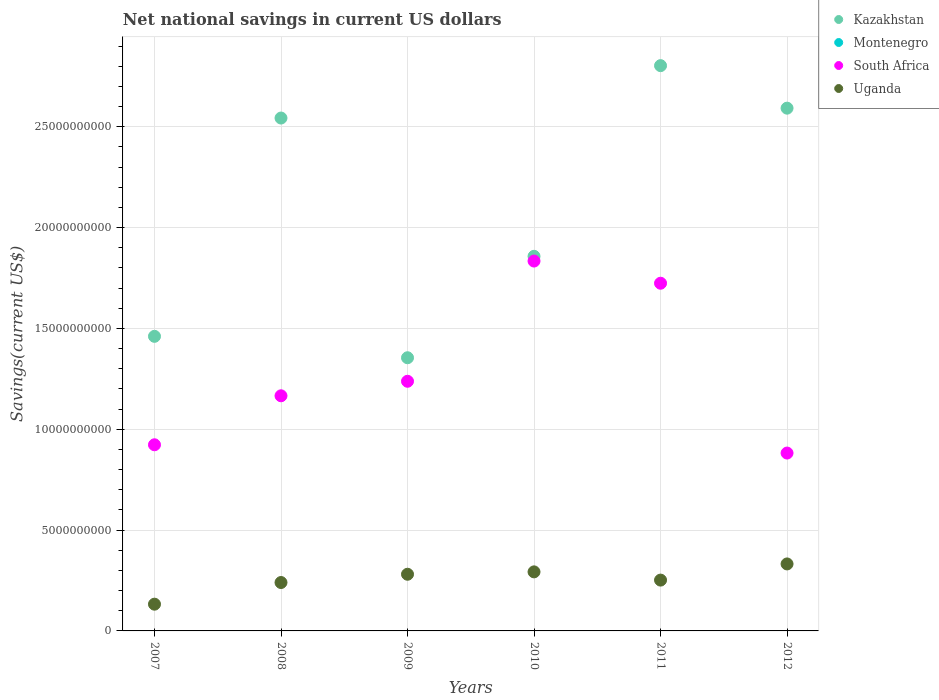What is the net national savings in Uganda in 2008?
Provide a succinct answer. 2.40e+09. Across all years, what is the maximum net national savings in Uganda?
Your answer should be very brief. 3.32e+09. Across all years, what is the minimum net national savings in Kazakhstan?
Your answer should be compact. 1.35e+1. What is the difference between the net national savings in South Africa in 2009 and that in 2012?
Keep it short and to the point. 3.56e+09. What is the difference between the net national savings in Montenegro in 2011 and the net national savings in Uganda in 2007?
Your response must be concise. -1.33e+09. What is the average net national savings in South Africa per year?
Offer a very short reply. 1.29e+1. In the year 2009, what is the difference between the net national savings in South Africa and net national savings in Uganda?
Offer a very short reply. 9.57e+09. What is the ratio of the net national savings in South Africa in 2007 to that in 2012?
Your answer should be very brief. 1.05. Is the net national savings in Uganda in 2008 less than that in 2011?
Your answer should be very brief. Yes. What is the difference between the highest and the second highest net national savings in Kazakhstan?
Provide a short and direct response. 2.11e+09. What is the difference between the highest and the lowest net national savings in South Africa?
Provide a succinct answer. 9.52e+09. Is it the case that in every year, the sum of the net national savings in Kazakhstan and net national savings in Uganda  is greater than the net national savings in Montenegro?
Offer a very short reply. Yes. Is the net national savings in Uganda strictly less than the net national savings in Kazakhstan over the years?
Provide a short and direct response. Yes. How many dotlines are there?
Keep it short and to the point. 3. Are the values on the major ticks of Y-axis written in scientific E-notation?
Your answer should be very brief. No. Does the graph contain any zero values?
Give a very brief answer. Yes. What is the title of the graph?
Your response must be concise. Net national savings in current US dollars. Does "Malaysia" appear as one of the legend labels in the graph?
Offer a terse response. No. What is the label or title of the Y-axis?
Ensure brevity in your answer.  Savings(current US$). What is the Savings(current US$) of Kazakhstan in 2007?
Give a very brief answer. 1.46e+1. What is the Savings(current US$) in South Africa in 2007?
Keep it short and to the point. 9.23e+09. What is the Savings(current US$) in Uganda in 2007?
Offer a terse response. 1.33e+09. What is the Savings(current US$) of Kazakhstan in 2008?
Give a very brief answer. 2.54e+1. What is the Savings(current US$) of South Africa in 2008?
Offer a very short reply. 1.17e+1. What is the Savings(current US$) of Uganda in 2008?
Provide a succinct answer. 2.40e+09. What is the Savings(current US$) of Kazakhstan in 2009?
Make the answer very short. 1.35e+1. What is the Savings(current US$) in South Africa in 2009?
Offer a terse response. 1.24e+1. What is the Savings(current US$) in Uganda in 2009?
Ensure brevity in your answer.  2.81e+09. What is the Savings(current US$) of Kazakhstan in 2010?
Offer a terse response. 1.86e+1. What is the Savings(current US$) in Montenegro in 2010?
Provide a short and direct response. 0. What is the Savings(current US$) in South Africa in 2010?
Provide a short and direct response. 1.83e+1. What is the Savings(current US$) of Uganda in 2010?
Your answer should be very brief. 2.93e+09. What is the Savings(current US$) of Kazakhstan in 2011?
Your answer should be very brief. 2.80e+1. What is the Savings(current US$) of Montenegro in 2011?
Your answer should be very brief. 0. What is the Savings(current US$) in South Africa in 2011?
Provide a succinct answer. 1.72e+1. What is the Savings(current US$) in Uganda in 2011?
Provide a succinct answer. 2.52e+09. What is the Savings(current US$) in Kazakhstan in 2012?
Offer a very short reply. 2.59e+1. What is the Savings(current US$) in South Africa in 2012?
Provide a succinct answer. 8.82e+09. What is the Savings(current US$) of Uganda in 2012?
Your response must be concise. 3.32e+09. Across all years, what is the maximum Savings(current US$) of Kazakhstan?
Your answer should be very brief. 2.80e+1. Across all years, what is the maximum Savings(current US$) in South Africa?
Offer a terse response. 1.83e+1. Across all years, what is the maximum Savings(current US$) of Uganda?
Your response must be concise. 3.32e+09. Across all years, what is the minimum Savings(current US$) of Kazakhstan?
Keep it short and to the point. 1.35e+1. Across all years, what is the minimum Savings(current US$) in South Africa?
Keep it short and to the point. 8.82e+09. Across all years, what is the minimum Savings(current US$) of Uganda?
Your answer should be very brief. 1.33e+09. What is the total Savings(current US$) of Kazakhstan in the graph?
Ensure brevity in your answer.  1.26e+11. What is the total Savings(current US$) of Montenegro in the graph?
Provide a short and direct response. 0. What is the total Savings(current US$) in South Africa in the graph?
Keep it short and to the point. 7.77e+1. What is the total Savings(current US$) in Uganda in the graph?
Your answer should be compact. 1.53e+1. What is the difference between the Savings(current US$) in Kazakhstan in 2007 and that in 2008?
Your answer should be very brief. -1.08e+1. What is the difference between the Savings(current US$) in South Africa in 2007 and that in 2008?
Your answer should be compact. -2.43e+09. What is the difference between the Savings(current US$) in Uganda in 2007 and that in 2008?
Provide a short and direct response. -1.07e+09. What is the difference between the Savings(current US$) in Kazakhstan in 2007 and that in 2009?
Your answer should be very brief. 1.06e+09. What is the difference between the Savings(current US$) of South Africa in 2007 and that in 2009?
Offer a terse response. -3.15e+09. What is the difference between the Savings(current US$) in Uganda in 2007 and that in 2009?
Keep it short and to the point. -1.48e+09. What is the difference between the Savings(current US$) of Kazakhstan in 2007 and that in 2010?
Give a very brief answer. -3.97e+09. What is the difference between the Savings(current US$) in South Africa in 2007 and that in 2010?
Your response must be concise. -9.11e+09. What is the difference between the Savings(current US$) of Uganda in 2007 and that in 2010?
Your answer should be very brief. -1.60e+09. What is the difference between the Savings(current US$) of Kazakhstan in 2007 and that in 2011?
Offer a terse response. -1.34e+1. What is the difference between the Savings(current US$) of South Africa in 2007 and that in 2011?
Your response must be concise. -8.01e+09. What is the difference between the Savings(current US$) in Uganda in 2007 and that in 2011?
Make the answer very short. -1.19e+09. What is the difference between the Savings(current US$) in Kazakhstan in 2007 and that in 2012?
Provide a short and direct response. -1.13e+1. What is the difference between the Savings(current US$) of South Africa in 2007 and that in 2012?
Provide a short and direct response. 4.10e+08. What is the difference between the Savings(current US$) in Uganda in 2007 and that in 2012?
Give a very brief answer. -2.00e+09. What is the difference between the Savings(current US$) in Kazakhstan in 2008 and that in 2009?
Give a very brief answer. 1.19e+1. What is the difference between the Savings(current US$) in South Africa in 2008 and that in 2009?
Make the answer very short. -7.20e+08. What is the difference between the Savings(current US$) of Uganda in 2008 and that in 2009?
Your answer should be compact. -4.10e+08. What is the difference between the Savings(current US$) in Kazakhstan in 2008 and that in 2010?
Your answer should be very brief. 6.86e+09. What is the difference between the Savings(current US$) of South Africa in 2008 and that in 2010?
Provide a short and direct response. -6.68e+09. What is the difference between the Savings(current US$) of Uganda in 2008 and that in 2010?
Your answer should be compact. -5.28e+08. What is the difference between the Savings(current US$) of Kazakhstan in 2008 and that in 2011?
Ensure brevity in your answer.  -2.60e+09. What is the difference between the Savings(current US$) in South Africa in 2008 and that in 2011?
Offer a terse response. -5.58e+09. What is the difference between the Savings(current US$) of Uganda in 2008 and that in 2011?
Your answer should be compact. -1.20e+08. What is the difference between the Savings(current US$) in Kazakhstan in 2008 and that in 2012?
Your response must be concise. -4.90e+08. What is the difference between the Savings(current US$) in South Africa in 2008 and that in 2012?
Ensure brevity in your answer.  2.84e+09. What is the difference between the Savings(current US$) of Uganda in 2008 and that in 2012?
Offer a very short reply. -9.22e+08. What is the difference between the Savings(current US$) in Kazakhstan in 2009 and that in 2010?
Make the answer very short. -5.03e+09. What is the difference between the Savings(current US$) in South Africa in 2009 and that in 2010?
Keep it short and to the point. -5.96e+09. What is the difference between the Savings(current US$) in Uganda in 2009 and that in 2010?
Provide a succinct answer. -1.18e+08. What is the difference between the Savings(current US$) of Kazakhstan in 2009 and that in 2011?
Your answer should be compact. -1.45e+1. What is the difference between the Savings(current US$) of South Africa in 2009 and that in 2011?
Your response must be concise. -4.86e+09. What is the difference between the Savings(current US$) of Uganda in 2009 and that in 2011?
Keep it short and to the point. 2.90e+08. What is the difference between the Savings(current US$) of Kazakhstan in 2009 and that in 2012?
Provide a short and direct response. -1.24e+1. What is the difference between the Savings(current US$) in South Africa in 2009 and that in 2012?
Keep it short and to the point. 3.56e+09. What is the difference between the Savings(current US$) in Uganda in 2009 and that in 2012?
Provide a succinct answer. -5.11e+08. What is the difference between the Savings(current US$) in Kazakhstan in 2010 and that in 2011?
Offer a very short reply. -9.46e+09. What is the difference between the Savings(current US$) in South Africa in 2010 and that in 2011?
Your answer should be compact. 1.10e+09. What is the difference between the Savings(current US$) in Uganda in 2010 and that in 2011?
Provide a short and direct response. 4.08e+08. What is the difference between the Savings(current US$) in Kazakhstan in 2010 and that in 2012?
Give a very brief answer. -7.35e+09. What is the difference between the Savings(current US$) of South Africa in 2010 and that in 2012?
Offer a terse response. 9.52e+09. What is the difference between the Savings(current US$) of Uganda in 2010 and that in 2012?
Ensure brevity in your answer.  -3.93e+08. What is the difference between the Savings(current US$) in Kazakhstan in 2011 and that in 2012?
Give a very brief answer. 2.11e+09. What is the difference between the Savings(current US$) of South Africa in 2011 and that in 2012?
Make the answer very short. 8.42e+09. What is the difference between the Savings(current US$) in Uganda in 2011 and that in 2012?
Your answer should be very brief. -8.02e+08. What is the difference between the Savings(current US$) of Kazakhstan in 2007 and the Savings(current US$) of South Africa in 2008?
Your response must be concise. 2.95e+09. What is the difference between the Savings(current US$) in Kazakhstan in 2007 and the Savings(current US$) in Uganda in 2008?
Your answer should be very brief. 1.22e+1. What is the difference between the Savings(current US$) of South Africa in 2007 and the Savings(current US$) of Uganda in 2008?
Give a very brief answer. 6.83e+09. What is the difference between the Savings(current US$) in Kazakhstan in 2007 and the Savings(current US$) in South Africa in 2009?
Ensure brevity in your answer.  2.23e+09. What is the difference between the Savings(current US$) of Kazakhstan in 2007 and the Savings(current US$) of Uganda in 2009?
Ensure brevity in your answer.  1.18e+1. What is the difference between the Savings(current US$) in South Africa in 2007 and the Savings(current US$) in Uganda in 2009?
Make the answer very short. 6.42e+09. What is the difference between the Savings(current US$) in Kazakhstan in 2007 and the Savings(current US$) in South Africa in 2010?
Keep it short and to the point. -3.73e+09. What is the difference between the Savings(current US$) in Kazakhstan in 2007 and the Savings(current US$) in Uganda in 2010?
Offer a very short reply. 1.17e+1. What is the difference between the Savings(current US$) of South Africa in 2007 and the Savings(current US$) of Uganda in 2010?
Your response must be concise. 6.30e+09. What is the difference between the Savings(current US$) in Kazakhstan in 2007 and the Savings(current US$) in South Africa in 2011?
Provide a succinct answer. -2.63e+09. What is the difference between the Savings(current US$) of Kazakhstan in 2007 and the Savings(current US$) of Uganda in 2011?
Your response must be concise. 1.21e+1. What is the difference between the Savings(current US$) in South Africa in 2007 and the Savings(current US$) in Uganda in 2011?
Provide a succinct answer. 6.71e+09. What is the difference between the Savings(current US$) of Kazakhstan in 2007 and the Savings(current US$) of South Africa in 2012?
Your response must be concise. 5.79e+09. What is the difference between the Savings(current US$) of Kazakhstan in 2007 and the Savings(current US$) of Uganda in 2012?
Provide a succinct answer. 1.13e+1. What is the difference between the Savings(current US$) of South Africa in 2007 and the Savings(current US$) of Uganda in 2012?
Offer a terse response. 5.91e+09. What is the difference between the Savings(current US$) in Kazakhstan in 2008 and the Savings(current US$) in South Africa in 2009?
Provide a short and direct response. 1.31e+1. What is the difference between the Savings(current US$) in Kazakhstan in 2008 and the Savings(current US$) in Uganda in 2009?
Your response must be concise. 2.26e+1. What is the difference between the Savings(current US$) in South Africa in 2008 and the Savings(current US$) in Uganda in 2009?
Offer a very short reply. 8.85e+09. What is the difference between the Savings(current US$) in Kazakhstan in 2008 and the Savings(current US$) in South Africa in 2010?
Ensure brevity in your answer.  7.09e+09. What is the difference between the Savings(current US$) of Kazakhstan in 2008 and the Savings(current US$) of Uganda in 2010?
Offer a very short reply. 2.25e+1. What is the difference between the Savings(current US$) of South Africa in 2008 and the Savings(current US$) of Uganda in 2010?
Your answer should be very brief. 8.73e+09. What is the difference between the Savings(current US$) of Kazakhstan in 2008 and the Savings(current US$) of South Africa in 2011?
Provide a succinct answer. 8.19e+09. What is the difference between the Savings(current US$) in Kazakhstan in 2008 and the Savings(current US$) in Uganda in 2011?
Your answer should be very brief. 2.29e+1. What is the difference between the Savings(current US$) of South Africa in 2008 and the Savings(current US$) of Uganda in 2011?
Provide a short and direct response. 9.14e+09. What is the difference between the Savings(current US$) of Kazakhstan in 2008 and the Savings(current US$) of South Africa in 2012?
Provide a succinct answer. 1.66e+1. What is the difference between the Savings(current US$) of Kazakhstan in 2008 and the Savings(current US$) of Uganda in 2012?
Keep it short and to the point. 2.21e+1. What is the difference between the Savings(current US$) of South Africa in 2008 and the Savings(current US$) of Uganda in 2012?
Provide a succinct answer. 8.34e+09. What is the difference between the Savings(current US$) in Kazakhstan in 2009 and the Savings(current US$) in South Africa in 2010?
Offer a very short reply. -4.80e+09. What is the difference between the Savings(current US$) in Kazakhstan in 2009 and the Savings(current US$) in Uganda in 2010?
Make the answer very short. 1.06e+1. What is the difference between the Savings(current US$) in South Africa in 2009 and the Savings(current US$) in Uganda in 2010?
Your answer should be very brief. 9.45e+09. What is the difference between the Savings(current US$) of Kazakhstan in 2009 and the Savings(current US$) of South Africa in 2011?
Provide a succinct answer. -3.70e+09. What is the difference between the Savings(current US$) in Kazakhstan in 2009 and the Savings(current US$) in Uganda in 2011?
Make the answer very short. 1.10e+1. What is the difference between the Savings(current US$) in South Africa in 2009 and the Savings(current US$) in Uganda in 2011?
Provide a short and direct response. 9.86e+09. What is the difference between the Savings(current US$) in Kazakhstan in 2009 and the Savings(current US$) in South Africa in 2012?
Offer a terse response. 4.73e+09. What is the difference between the Savings(current US$) in Kazakhstan in 2009 and the Savings(current US$) in Uganda in 2012?
Your answer should be compact. 1.02e+1. What is the difference between the Savings(current US$) of South Africa in 2009 and the Savings(current US$) of Uganda in 2012?
Your answer should be compact. 9.06e+09. What is the difference between the Savings(current US$) in Kazakhstan in 2010 and the Savings(current US$) in South Africa in 2011?
Provide a succinct answer. 1.33e+09. What is the difference between the Savings(current US$) of Kazakhstan in 2010 and the Savings(current US$) of Uganda in 2011?
Offer a very short reply. 1.61e+1. What is the difference between the Savings(current US$) in South Africa in 2010 and the Savings(current US$) in Uganda in 2011?
Ensure brevity in your answer.  1.58e+1. What is the difference between the Savings(current US$) of Kazakhstan in 2010 and the Savings(current US$) of South Africa in 2012?
Provide a succinct answer. 9.76e+09. What is the difference between the Savings(current US$) in Kazakhstan in 2010 and the Savings(current US$) in Uganda in 2012?
Provide a short and direct response. 1.53e+1. What is the difference between the Savings(current US$) in South Africa in 2010 and the Savings(current US$) in Uganda in 2012?
Give a very brief answer. 1.50e+1. What is the difference between the Savings(current US$) of Kazakhstan in 2011 and the Savings(current US$) of South Africa in 2012?
Give a very brief answer. 1.92e+1. What is the difference between the Savings(current US$) in Kazakhstan in 2011 and the Savings(current US$) in Uganda in 2012?
Your answer should be very brief. 2.47e+1. What is the difference between the Savings(current US$) in South Africa in 2011 and the Savings(current US$) in Uganda in 2012?
Ensure brevity in your answer.  1.39e+1. What is the average Savings(current US$) of Kazakhstan per year?
Offer a terse response. 2.10e+1. What is the average Savings(current US$) in Montenegro per year?
Your response must be concise. 0. What is the average Savings(current US$) in South Africa per year?
Give a very brief answer. 1.29e+1. What is the average Savings(current US$) in Uganda per year?
Offer a terse response. 2.55e+09. In the year 2007, what is the difference between the Savings(current US$) in Kazakhstan and Savings(current US$) in South Africa?
Offer a terse response. 5.38e+09. In the year 2007, what is the difference between the Savings(current US$) in Kazakhstan and Savings(current US$) in Uganda?
Keep it short and to the point. 1.33e+1. In the year 2007, what is the difference between the Savings(current US$) of South Africa and Savings(current US$) of Uganda?
Ensure brevity in your answer.  7.90e+09. In the year 2008, what is the difference between the Savings(current US$) of Kazakhstan and Savings(current US$) of South Africa?
Ensure brevity in your answer.  1.38e+1. In the year 2008, what is the difference between the Savings(current US$) of Kazakhstan and Savings(current US$) of Uganda?
Your answer should be very brief. 2.30e+1. In the year 2008, what is the difference between the Savings(current US$) of South Africa and Savings(current US$) of Uganda?
Keep it short and to the point. 9.26e+09. In the year 2009, what is the difference between the Savings(current US$) of Kazakhstan and Savings(current US$) of South Africa?
Keep it short and to the point. 1.17e+09. In the year 2009, what is the difference between the Savings(current US$) in Kazakhstan and Savings(current US$) in Uganda?
Your response must be concise. 1.07e+1. In the year 2009, what is the difference between the Savings(current US$) in South Africa and Savings(current US$) in Uganda?
Your answer should be very brief. 9.57e+09. In the year 2010, what is the difference between the Savings(current US$) in Kazakhstan and Savings(current US$) in South Africa?
Make the answer very short. 2.35e+08. In the year 2010, what is the difference between the Savings(current US$) of Kazakhstan and Savings(current US$) of Uganda?
Provide a succinct answer. 1.56e+1. In the year 2010, what is the difference between the Savings(current US$) in South Africa and Savings(current US$) in Uganda?
Your answer should be compact. 1.54e+1. In the year 2011, what is the difference between the Savings(current US$) of Kazakhstan and Savings(current US$) of South Africa?
Ensure brevity in your answer.  1.08e+1. In the year 2011, what is the difference between the Savings(current US$) of Kazakhstan and Savings(current US$) of Uganda?
Provide a short and direct response. 2.55e+1. In the year 2011, what is the difference between the Savings(current US$) of South Africa and Savings(current US$) of Uganda?
Provide a succinct answer. 1.47e+1. In the year 2012, what is the difference between the Savings(current US$) in Kazakhstan and Savings(current US$) in South Africa?
Provide a short and direct response. 1.71e+1. In the year 2012, what is the difference between the Savings(current US$) of Kazakhstan and Savings(current US$) of Uganda?
Your answer should be very brief. 2.26e+1. In the year 2012, what is the difference between the Savings(current US$) in South Africa and Savings(current US$) in Uganda?
Keep it short and to the point. 5.50e+09. What is the ratio of the Savings(current US$) of Kazakhstan in 2007 to that in 2008?
Your answer should be compact. 0.57. What is the ratio of the Savings(current US$) of South Africa in 2007 to that in 2008?
Ensure brevity in your answer.  0.79. What is the ratio of the Savings(current US$) of Uganda in 2007 to that in 2008?
Ensure brevity in your answer.  0.55. What is the ratio of the Savings(current US$) of Kazakhstan in 2007 to that in 2009?
Your response must be concise. 1.08. What is the ratio of the Savings(current US$) in South Africa in 2007 to that in 2009?
Provide a short and direct response. 0.75. What is the ratio of the Savings(current US$) of Uganda in 2007 to that in 2009?
Provide a succinct answer. 0.47. What is the ratio of the Savings(current US$) of Kazakhstan in 2007 to that in 2010?
Keep it short and to the point. 0.79. What is the ratio of the Savings(current US$) in South Africa in 2007 to that in 2010?
Provide a short and direct response. 0.5. What is the ratio of the Savings(current US$) of Uganda in 2007 to that in 2010?
Your response must be concise. 0.45. What is the ratio of the Savings(current US$) in Kazakhstan in 2007 to that in 2011?
Offer a terse response. 0.52. What is the ratio of the Savings(current US$) in South Africa in 2007 to that in 2011?
Give a very brief answer. 0.54. What is the ratio of the Savings(current US$) in Uganda in 2007 to that in 2011?
Your response must be concise. 0.53. What is the ratio of the Savings(current US$) in Kazakhstan in 2007 to that in 2012?
Offer a terse response. 0.56. What is the ratio of the Savings(current US$) of South Africa in 2007 to that in 2012?
Your answer should be compact. 1.05. What is the ratio of the Savings(current US$) of Uganda in 2007 to that in 2012?
Make the answer very short. 0.4. What is the ratio of the Savings(current US$) in Kazakhstan in 2008 to that in 2009?
Give a very brief answer. 1.88. What is the ratio of the Savings(current US$) of South Africa in 2008 to that in 2009?
Provide a succinct answer. 0.94. What is the ratio of the Savings(current US$) of Uganda in 2008 to that in 2009?
Offer a terse response. 0.85. What is the ratio of the Savings(current US$) of Kazakhstan in 2008 to that in 2010?
Your answer should be compact. 1.37. What is the ratio of the Savings(current US$) of South Africa in 2008 to that in 2010?
Your answer should be compact. 0.64. What is the ratio of the Savings(current US$) of Uganda in 2008 to that in 2010?
Your answer should be very brief. 0.82. What is the ratio of the Savings(current US$) of Kazakhstan in 2008 to that in 2011?
Keep it short and to the point. 0.91. What is the ratio of the Savings(current US$) of South Africa in 2008 to that in 2011?
Your answer should be very brief. 0.68. What is the ratio of the Savings(current US$) of Uganda in 2008 to that in 2011?
Your answer should be very brief. 0.95. What is the ratio of the Savings(current US$) in Kazakhstan in 2008 to that in 2012?
Make the answer very short. 0.98. What is the ratio of the Savings(current US$) in South Africa in 2008 to that in 2012?
Ensure brevity in your answer.  1.32. What is the ratio of the Savings(current US$) in Uganda in 2008 to that in 2012?
Your response must be concise. 0.72. What is the ratio of the Savings(current US$) in Kazakhstan in 2009 to that in 2010?
Keep it short and to the point. 0.73. What is the ratio of the Savings(current US$) in South Africa in 2009 to that in 2010?
Make the answer very short. 0.68. What is the ratio of the Savings(current US$) of Uganda in 2009 to that in 2010?
Your answer should be compact. 0.96. What is the ratio of the Savings(current US$) of Kazakhstan in 2009 to that in 2011?
Keep it short and to the point. 0.48. What is the ratio of the Savings(current US$) in South Africa in 2009 to that in 2011?
Ensure brevity in your answer.  0.72. What is the ratio of the Savings(current US$) of Uganda in 2009 to that in 2011?
Give a very brief answer. 1.12. What is the ratio of the Savings(current US$) of Kazakhstan in 2009 to that in 2012?
Provide a succinct answer. 0.52. What is the ratio of the Savings(current US$) in South Africa in 2009 to that in 2012?
Keep it short and to the point. 1.4. What is the ratio of the Savings(current US$) of Uganda in 2009 to that in 2012?
Keep it short and to the point. 0.85. What is the ratio of the Savings(current US$) in Kazakhstan in 2010 to that in 2011?
Offer a very short reply. 0.66. What is the ratio of the Savings(current US$) in South Africa in 2010 to that in 2011?
Make the answer very short. 1.06. What is the ratio of the Savings(current US$) in Uganda in 2010 to that in 2011?
Give a very brief answer. 1.16. What is the ratio of the Savings(current US$) of Kazakhstan in 2010 to that in 2012?
Offer a very short reply. 0.72. What is the ratio of the Savings(current US$) of South Africa in 2010 to that in 2012?
Offer a very short reply. 2.08. What is the ratio of the Savings(current US$) in Uganda in 2010 to that in 2012?
Provide a short and direct response. 0.88. What is the ratio of the Savings(current US$) in Kazakhstan in 2011 to that in 2012?
Provide a succinct answer. 1.08. What is the ratio of the Savings(current US$) in South Africa in 2011 to that in 2012?
Ensure brevity in your answer.  1.95. What is the ratio of the Savings(current US$) in Uganda in 2011 to that in 2012?
Offer a terse response. 0.76. What is the difference between the highest and the second highest Savings(current US$) in Kazakhstan?
Your answer should be compact. 2.11e+09. What is the difference between the highest and the second highest Savings(current US$) of South Africa?
Your response must be concise. 1.10e+09. What is the difference between the highest and the second highest Savings(current US$) of Uganda?
Offer a very short reply. 3.93e+08. What is the difference between the highest and the lowest Savings(current US$) in Kazakhstan?
Your answer should be compact. 1.45e+1. What is the difference between the highest and the lowest Savings(current US$) of South Africa?
Provide a succinct answer. 9.52e+09. What is the difference between the highest and the lowest Savings(current US$) in Uganda?
Provide a succinct answer. 2.00e+09. 